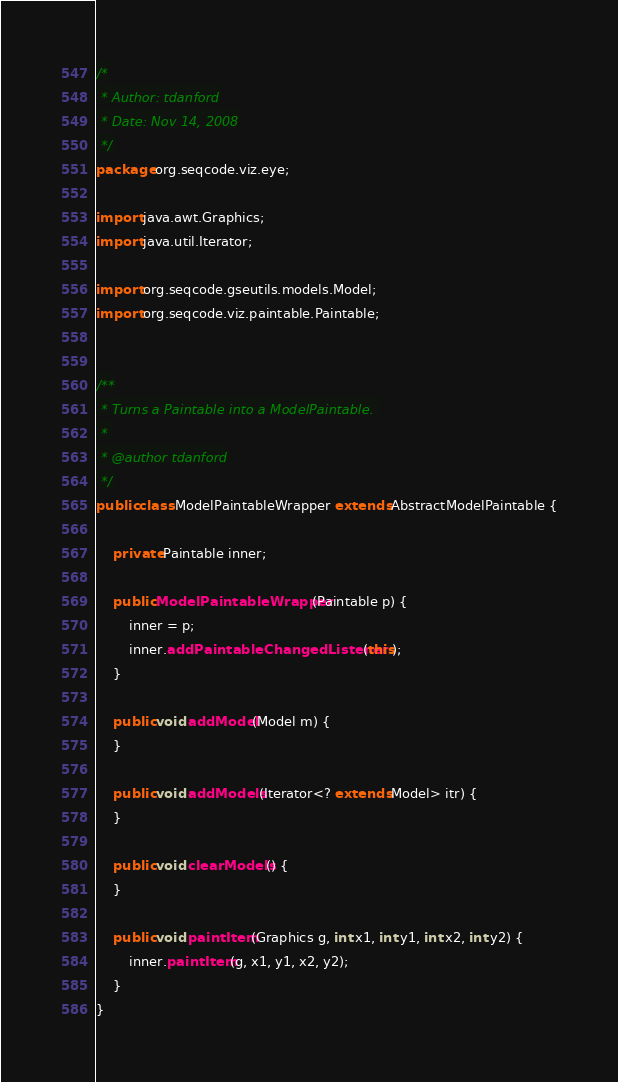Convert code to text. <code><loc_0><loc_0><loc_500><loc_500><_Java_>/*
 * Author: tdanford
 * Date: Nov 14, 2008
 */
package org.seqcode.viz.eye;

import java.awt.Graphics;
import java.util.Iterator;

import org.seqcode.gseutils.models.Model;
import org.seqcode.viz.paintable.Paintable;


/**
 * Turns a Paintable into a ModelPaintable. 
 * 
 * @author tdanford
 */
public class ModelPaintableWrapper extends AbstractModelPaintable {

	private Paintable inner;
	
	public ModelPaintableWrapper(Paintable p) { 
		inner = p;
		inner.addPaintableChangedListener(this);
	}

	public void addModel(Model m) {
	}

	public void addModels(Iterator<? extends Model> itr) {
	}

	public void clearModels() {
	}

	public void paintItem(Graphics g, int x1, int y1, int x2, int y2) {
		inner.paintItem(g, x1, y1, x2, y2);
	}
}
</code> 